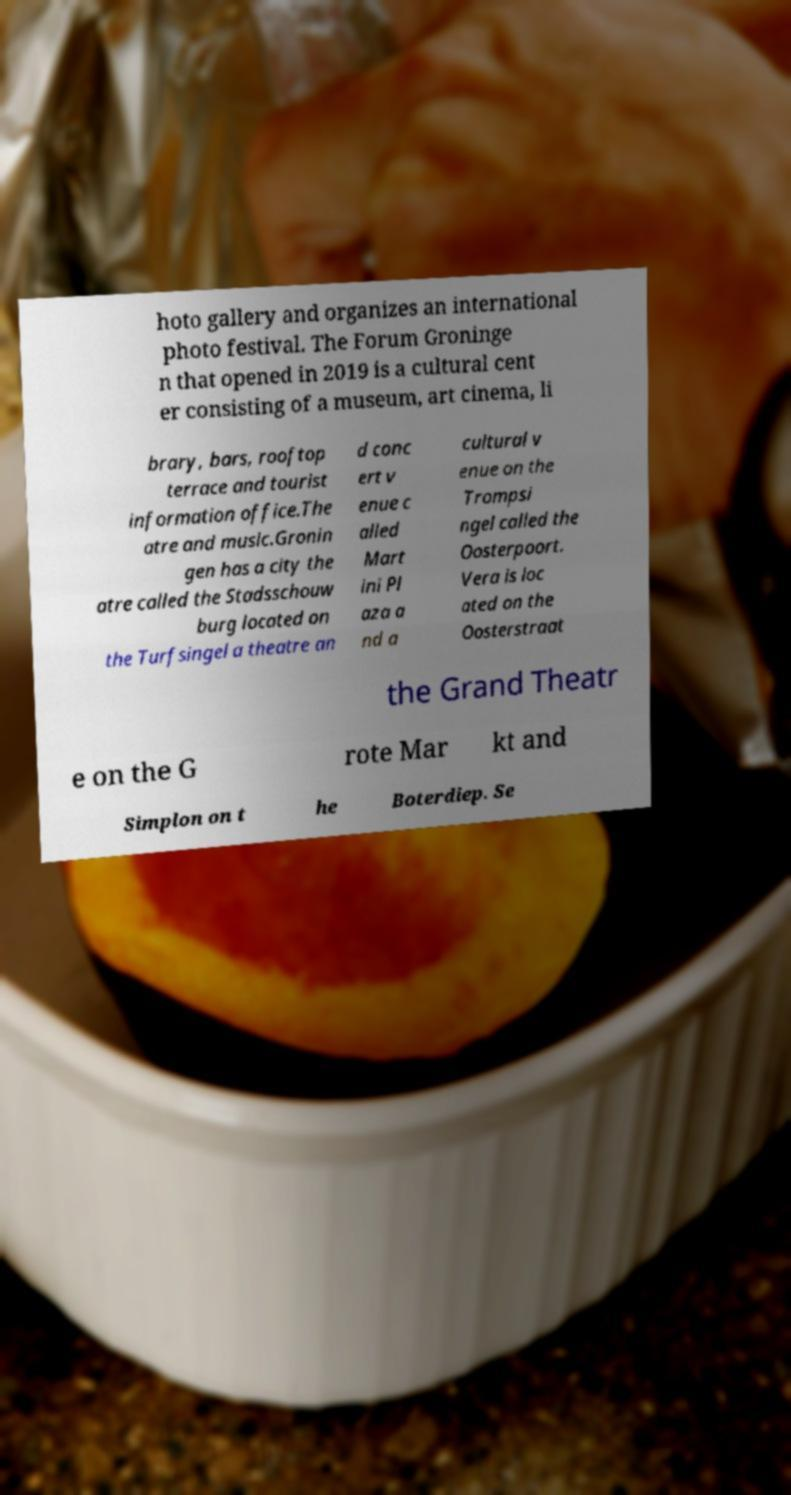Can you read and provide the text displayed in the image?This photo seems to have some interesting text. Can you extract and type it out for me? hoto gallery and organizes an international photo festival. The Forum Groninge n that opened in 2019 is a cultural cent er consisting of a museum, art cinema, li brary, bars, rooftop terrace and tourist information office.The atre and music.Gronin gen has a city the atre called the Stadsschouw burg located on the Turfsingel a theatre an d conc ert v enue c alled Mart ini Pl aza a nd a cultural v enue on the Trompsi ngel called the Oosterpoort. Vera is loc ated on the Oosterstraat the Grand Theatr e on the G rote Mar kt and Simplon on t he Boterdiep. Se 